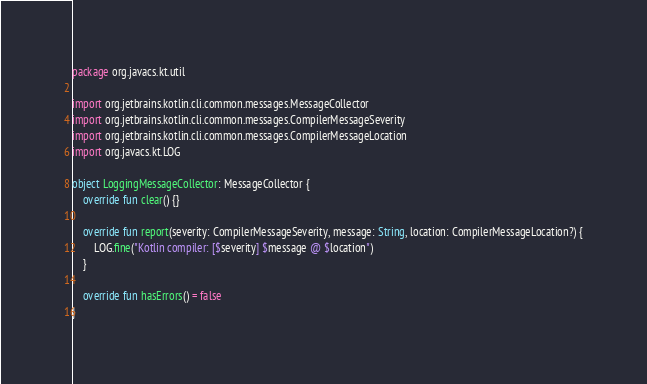Convert code to text. <code><loc_0><loc_0><loc_500><loc_500><_Kotlin_>package org.javacs.kt.util

import org.jetbrains.kotlin.cli.common.messages.MessageCollector
import org.jetbrains.kotlin.cli.common.messages.CompilerMessageSeverity
import org.jetbrains.kotlin.cli.common.messages.CompilerMessageLocation
import org.javacs.kt.LOG

object LoggingMessageCollector: MessageCollector {
	override fun clear() {}

	override fun report(severity: CompilerMessageSeverity, message: String, location: CompilerMessageLocation?) {
		LOG.fine("Kotlin compiler: [$severity] $message @ $location")
	}

	override fun hasErrors() = false
}
</code> 